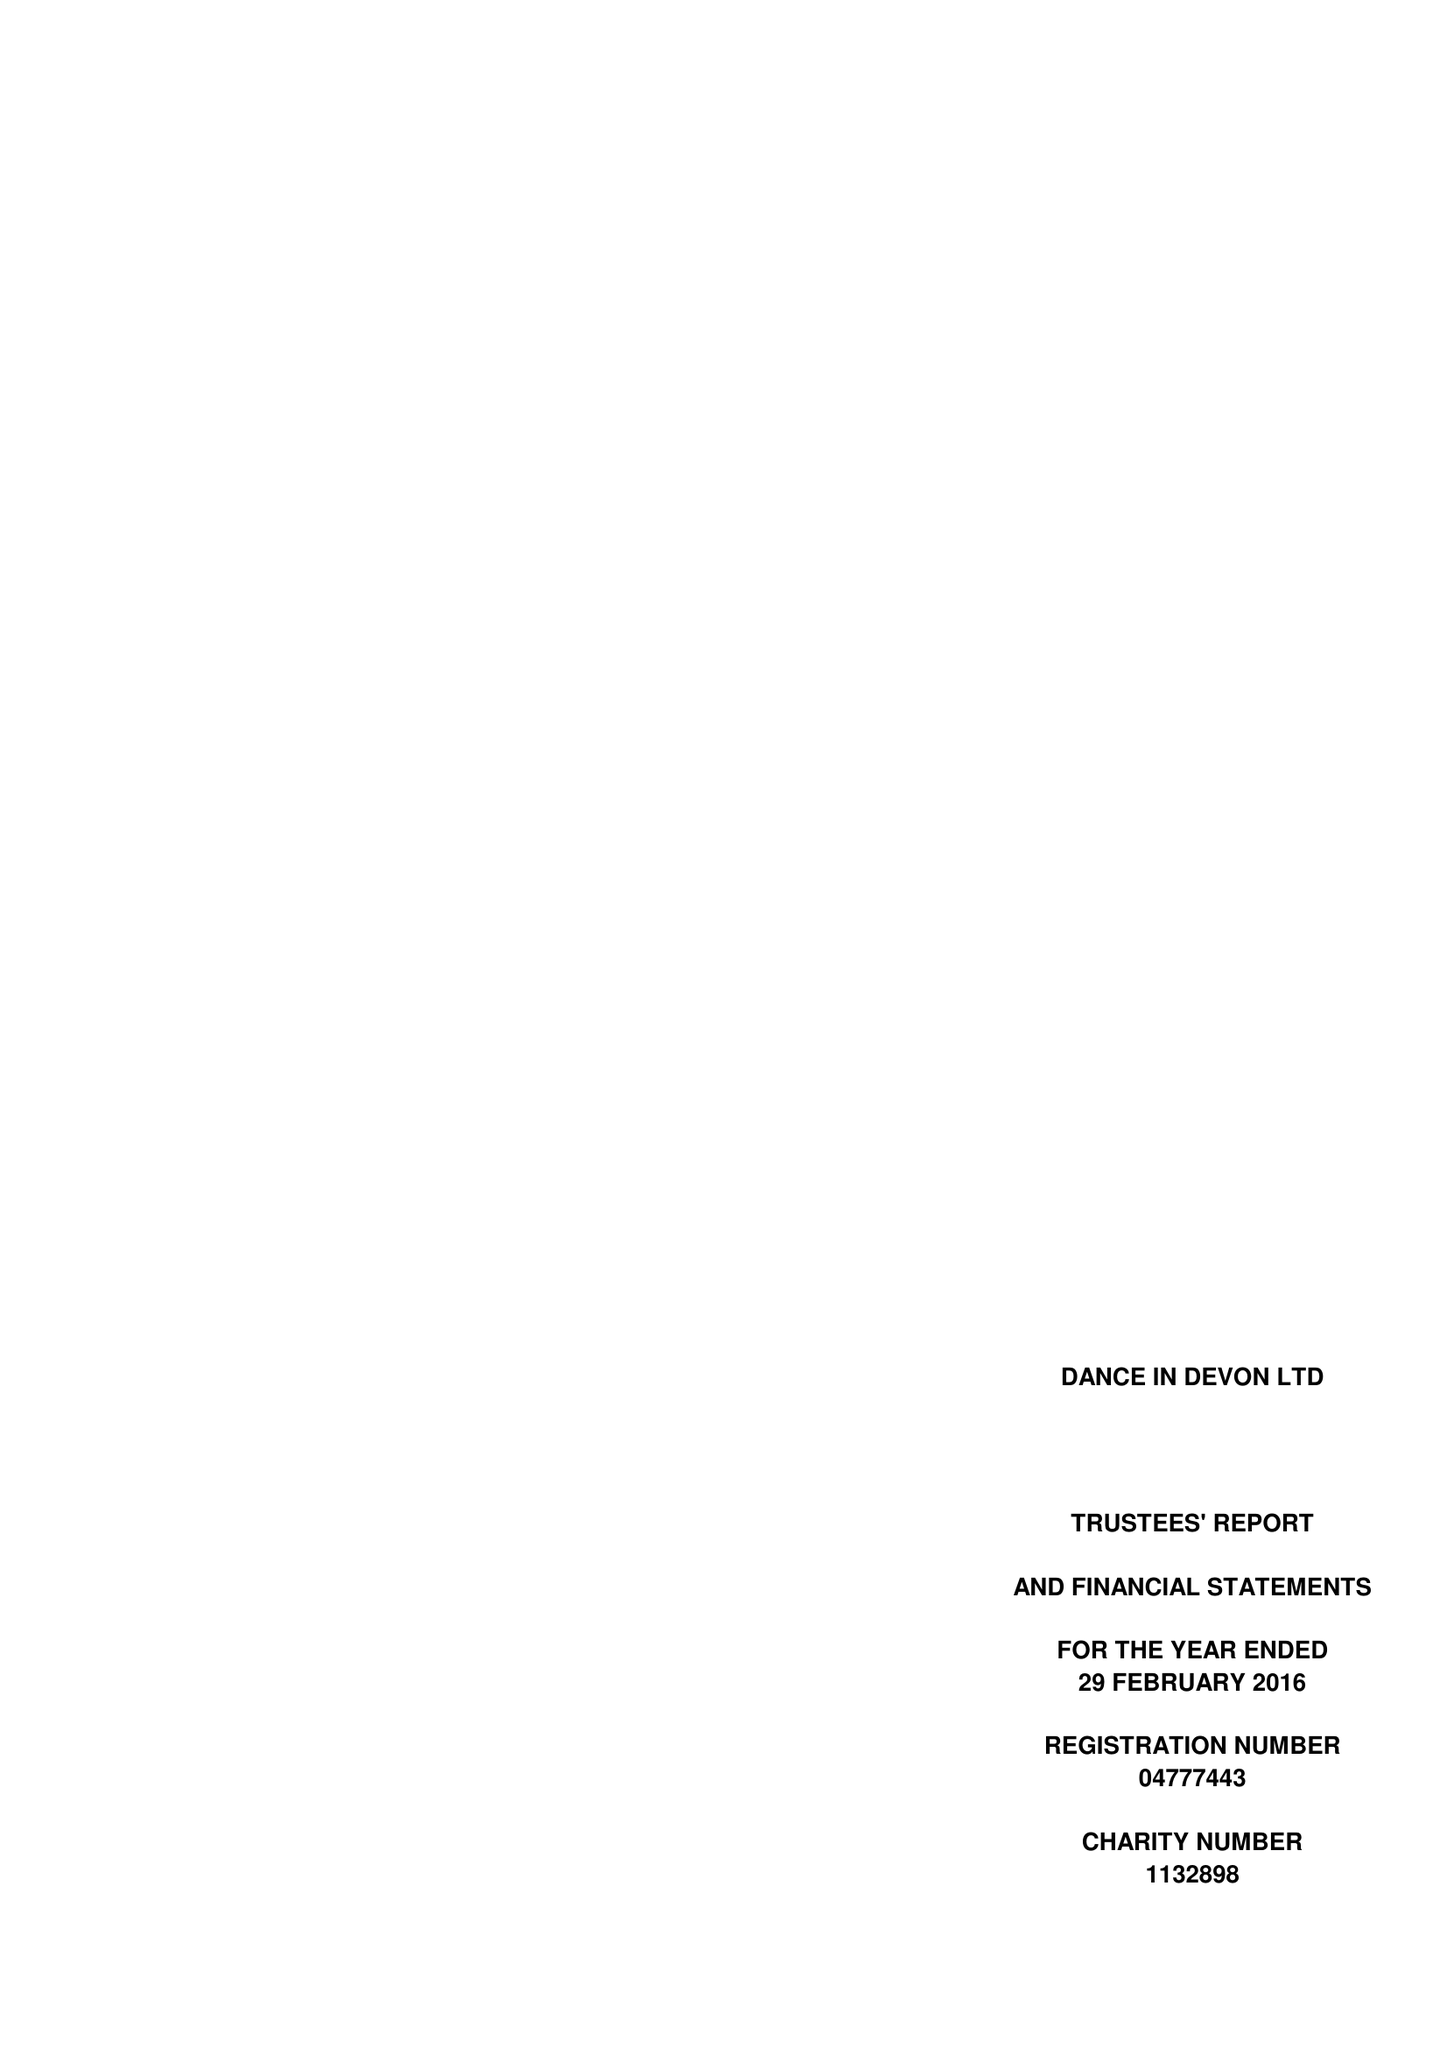What is the value for the address__street_line?
Answer the question using a single word or phrase. None 